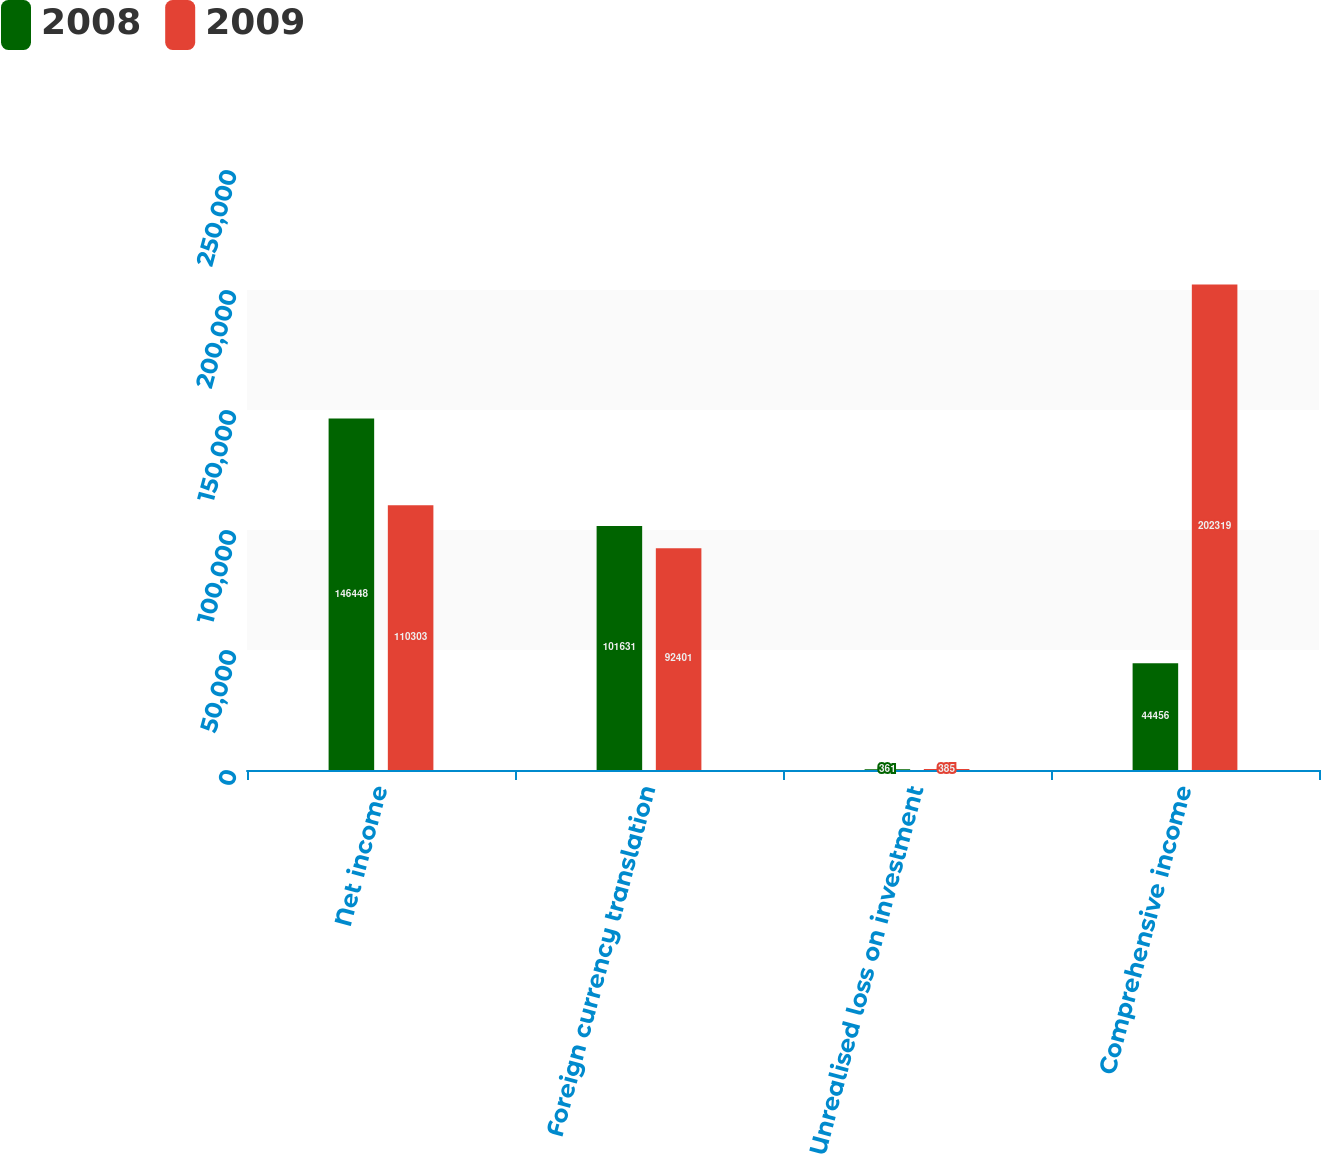Convert chart to OTSL. <chart><loc_0><loc_0><loc_500><loc_500><stacked_bar_chart><ecel><fcel>Net income<fcel>Foreign currency translation<fcel>Unrealised loss on investment<fcel>Comprehensive income<nl><fcel>2008<fcel>146448<fcel>101631<fcel>361<fcel>44456<nl><fcel>2009<fcel>110303<fcel>92401<fcel>385<fcel>202319<nl></chart> 